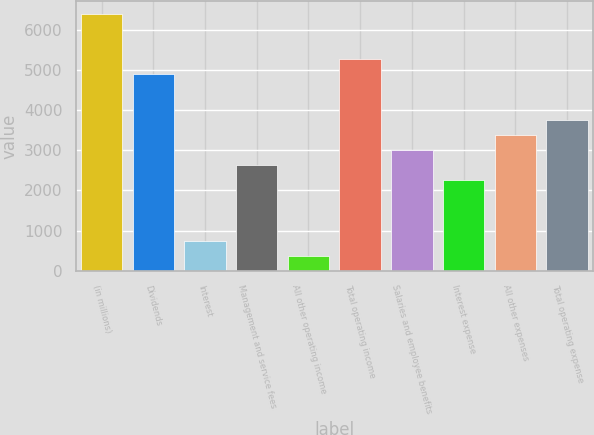Convert chart. <chart><loc_0><loc_0><loc_500><loc_500><bar_chart><fcel>(in millions)<fcel>Dividends<fcel>Interest<fcel>Management and service fees<fcel>All other operating income<fcel>Total operating income<fcel>Salaries and employee benefits<fcel>Interest expense<fcel>All other expenses<fcel>Total operating expense<nl><fcel>6394.7<fcel>4890.3<fcel>753.2<fcel>2633.7<fcel>377.1<fcel>5266.4<fcel>3009.8<fcel>2257.6<fcel>3385.9<fcel>3762<nl></chart> 